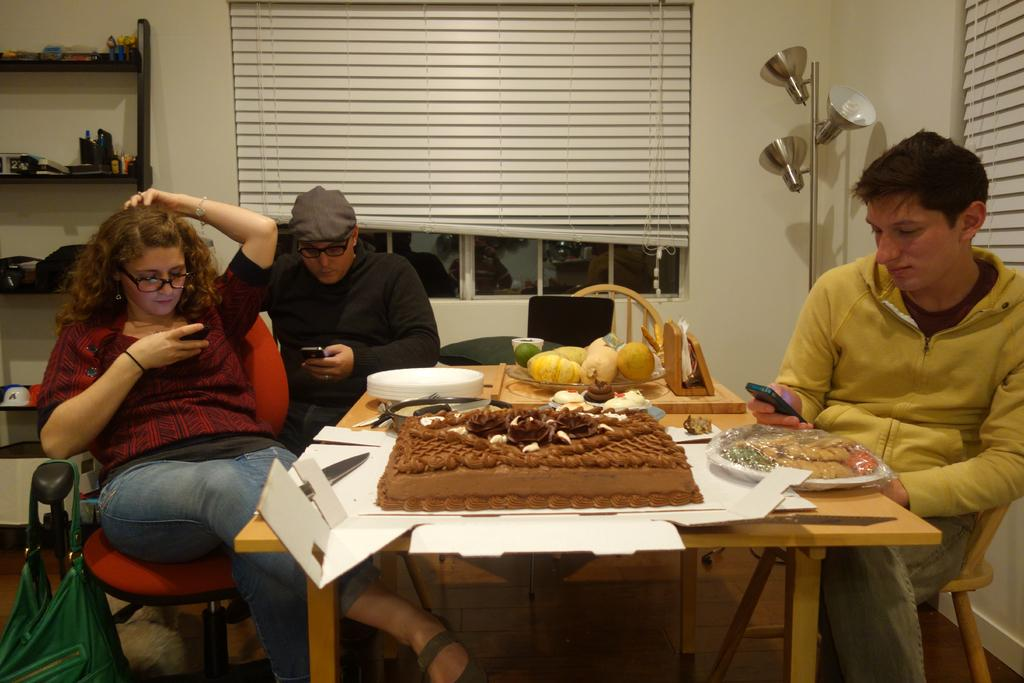How many people are sitting on chairs in the image? There are three persons sitting on chairs in the image. What is on one of the chairs? There is a bag on a chair. What is on the table in the image? There is a cake and fruits on the table. What else can be seen on the table? There are plates on the table. What is the man holding in the image? The man is holding a mobile. What type of art can be seen on the floor in the image? There is no art visible on the floor in the image. How much dirt is present on the cake in the image? There is no dirt present on the cake in the image; it appears clean. 